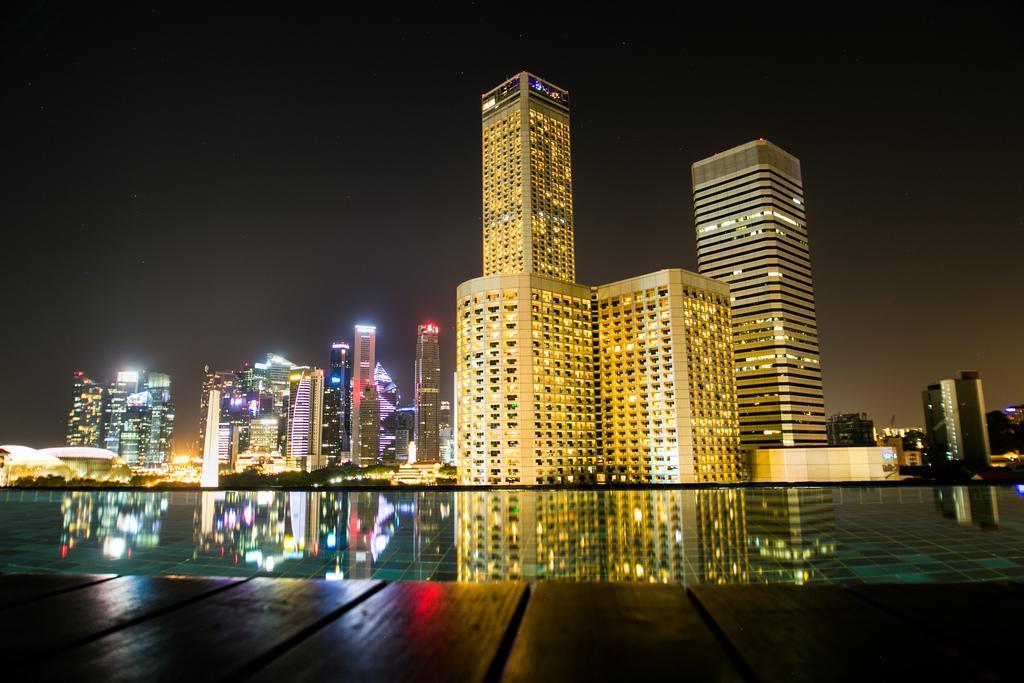Could you give a brief overview of what you see in this image? In this image, we can see some buildings. Among them, we can see some buildings with lights. We can see some water and the reflection of the buildings in the water. We can also see the ground and the sky. 